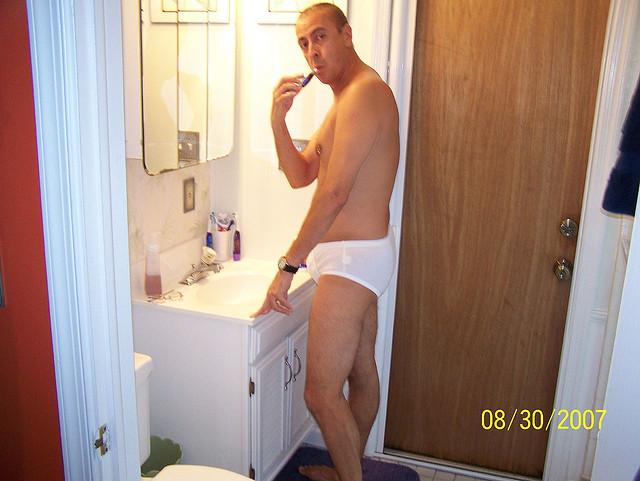Is the man standing in a hallway?
Be succinct. No. What is the man holding?
Answer briefly. Toothbrush. How many locks are on the door?
Give a very brief answer. 2. What is the man doing?
Give a very brief answer. Brushing teeth. Is this man wearing underwear?
Keep it brief. Yes. 